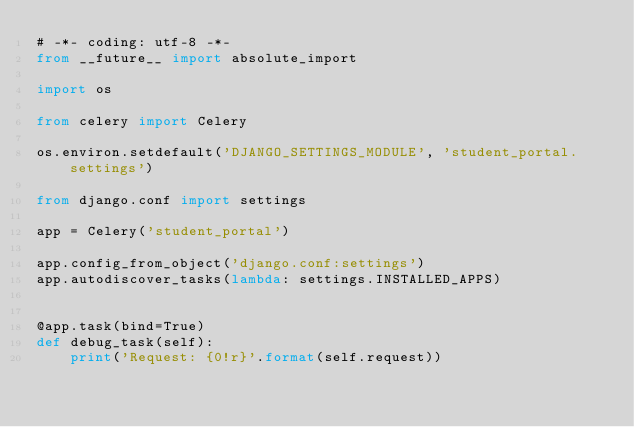Convert code to text. <code><loc_0><loc_0><loc_500><loc_500><_Python_># -*- coding: utf-8 -*-
from __future__ import absolute_import

import os

from celery import Celery

os.environ.setdefault('DJANGO_SETTINGS_MODULE', 'student_portal.settings')

from django.conf import settings 

app = Celery('student_portal')

app.config_from_object('django.conf:settings')
app.autodiscover_tasks(lambda: settings.INSTALLED_APPS)


@app.task(bind=True)
def debug_task(self):
    print('Request: {0!r}'.format(self.request))</code> 